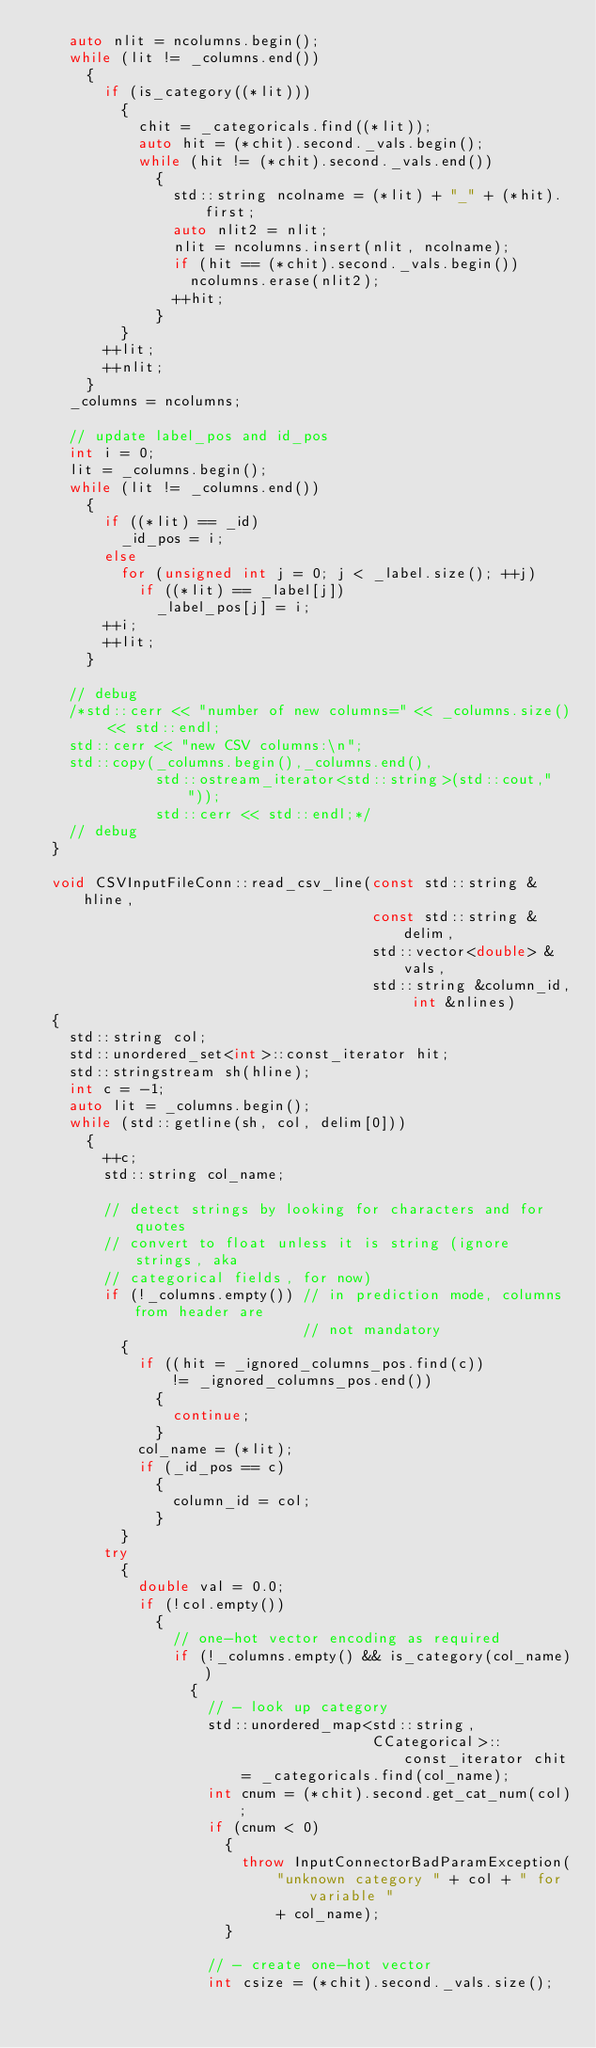Convert code to text. <code><loc_0><loc_0><loc_500><loc_500><_C++_>    auto nlit = ncolumns.begin();
    while (lit != _columns.end())
      {
        if (is_category((*lit)))
          {
            chit = _categoricals.find((*lit));
            auto hit = (*chit).second._vals.begin();
            while (hit != (*chit).second._vals.end())
              {
                std::string ncolname = (*lit) + "_" + (*hit).first;
                auto nlit2 = nlit;
                nlit = ncolumns.insert(nlit, ncolname);
                if (hit == (*chit).second._vals.begin())
                  ncolumns.erase(nlit2);
                ++hit;
              }
          }
        ++lit;
        ++nlit;
      }
    _columns = ncolumns;

    // update label_pos and id_pos
    int i = 0;
    lit = _columns.begin();
    while (lit != _columns.end())
      {
        if ((*lit) == _id)
          _id_pos = i;
        else
          for (unsigned int j = 0; j < _label.size(); ++j)
            if ((*lit) == _label[j])
              _label_pos[j] = i;
        ++i;
        ++lit;
      }

    // debug
    /*std::cerr << "number of new columns=" << _columns.size() << std::endl;
    std::cerr << "new CSV columns:\n";
    std::copy(_columns.begin(),_columns.end(),
              std::ostream_iterator<std::string>(std::cout," "));
              std::cerr << std::endl;*/
    // debug
  }

  void CSVInputFileConn::read_csv_line(const std::string &hline,
                                       const std::string &delim,
                                       std::vector<double> &vals,
                                       std::string &column_id, int &nlines)
  {
    std::string col;
    std::unordered_set<int>::const_iterator hit;
    std::stringstream sh(hline);
    int c = -1;
    auto lit = _columns.begin();
    while (std::getline(sh, col, delim[0]))
      {
        ++c;
        std::string col_name;

        // detect strings by looking for characters and for quotes
        // convert to float unless it is string (ignore strings, aka
        // categorical fields, for now)
        if (!_columns.empty()) // in prediction mode, columns from header are
                               // not mandatory
          {
            if ((hit = _ignored_columns_pos.find(c))
                != _ignored_columns_pos.end())
              {
                continue;
              }
            col_name = (*lit);
            if (_id_pos == c)
              {
                column_id = col;
              }
          }
        try
          {
            double val = 0.0;
            if (!col.empty())
              {
                // one-hot vector encoding as required
                if (!_columns.empty() && is_category(col_name))
                  {
                    // - look up category
                    std::unordered_map<std::string,
                                       CCategorical>::const_iterator chit
                        = _categoricals.find(col_name);
                    int cnum = (*chit).second.get_cat_num(col);
                    if (cnum < 0)
                      {
                        throw InputConnectorBadParamException(
                            "unknown category " + col + " for variable "
                            + col_name);
                      }

                    // - create one-hot vector
                    int csize = (*chit).second._vals.size();</code> 